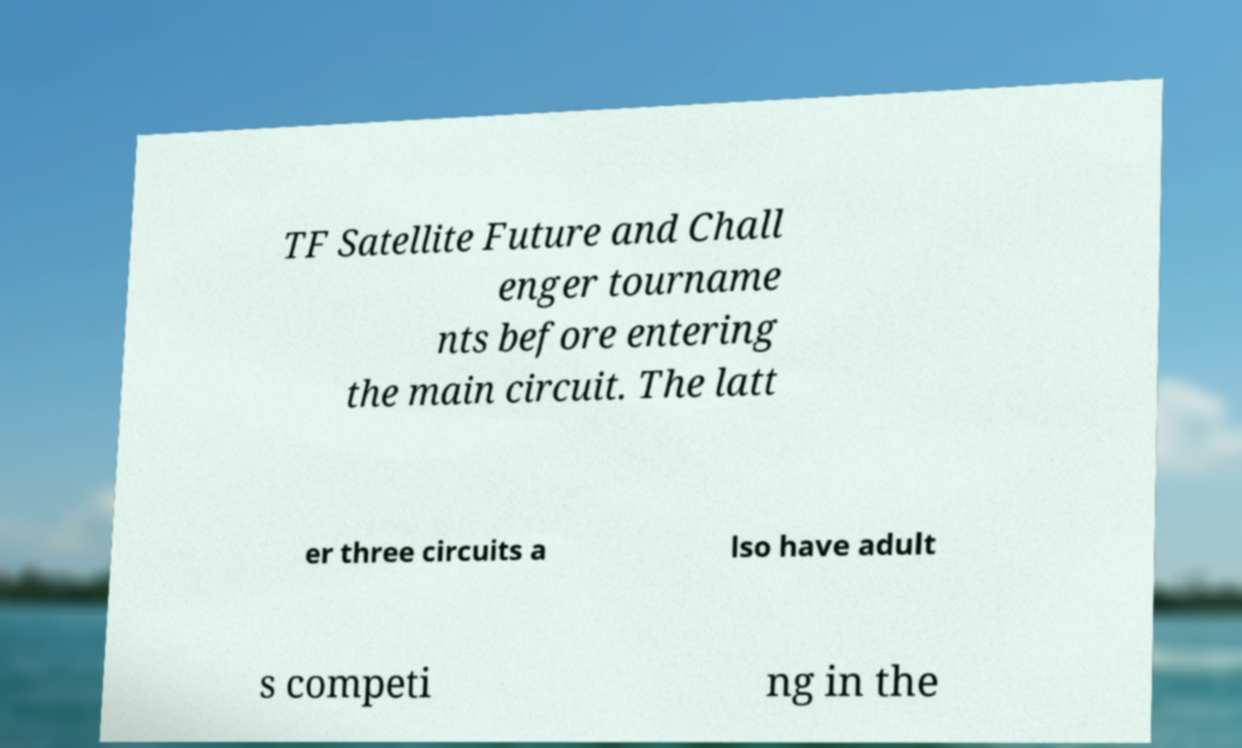Can you read and provide the text displayed in the image?This photo seems to have some interesting text. Can you extract and type it out for me? TF Satellite Future and Chall enger tourname nts before entering the main circuit. The latt er three circuits a lso have adult s competi ng in the 